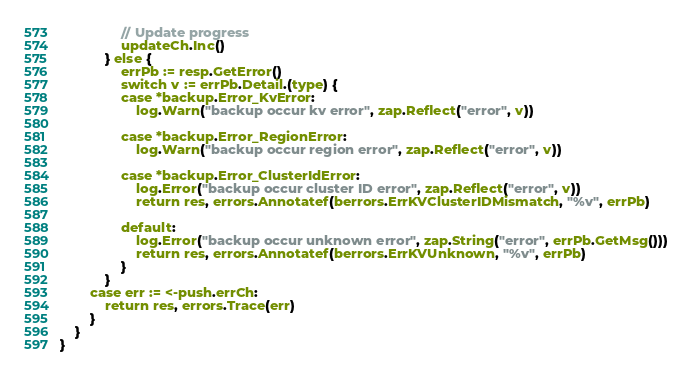<code> <loc_0><loc_0><loc_500><loc_500><_Go_>				// Update progress
				updateCh.Inc()
			} else {
				errPb := resp.GetError()
				switch v := errPb.Detail.(type) {
				case *backup.Error_KvError:
					log.Warn("backup occur kv error", zap.Reflect("error", v))

				case *backup.Error_RegionError:
					log.Warn("backup occur region error", zap.Reflect("error", v))

				case *backup.Error_ClusterIdError:
					log.Error("backup occur cluster ID error", zap.Reflect("error", v))
					return res, errors.Annotatef(berrors.ErrKVClusterIDMismatch, "%v", errPb)

				default:
					log.Error("backup occur unknown error", zap.String("error", errPb.GetMsg()))
					return res, errors.Annotatef(berrors.ErrKVUnknown, "%v", errPb)
				}
			}
		case err := <-push.errCh:
			return res, errors.Trace(err)
		}
	}
}
</code> 